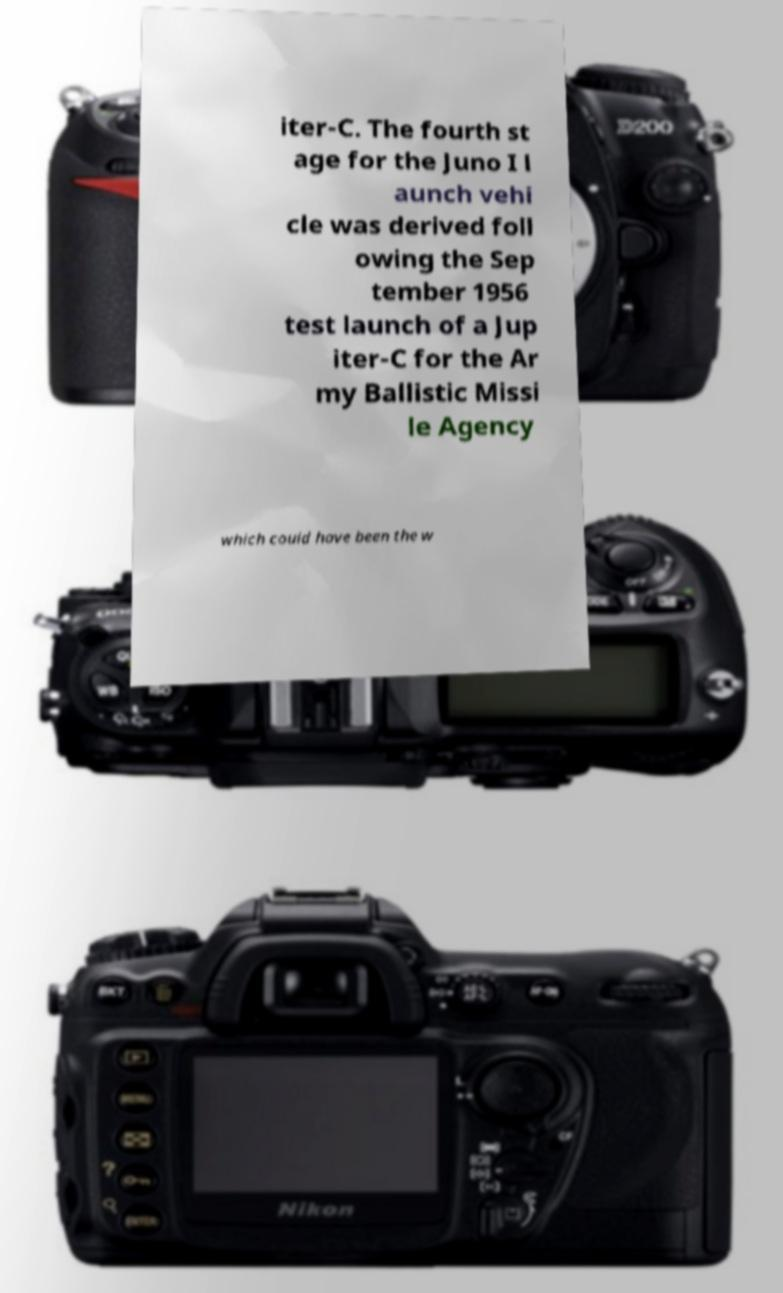Please read and relay the text visible in this image. What does it say? iter-C. The fourth st age for the Juno I l aunch vehi cle was derived foll owing the Sep tember 1956 test launch of a Jup iter-C for the Ar my Ballistic Missi le Agency which could have been the w 